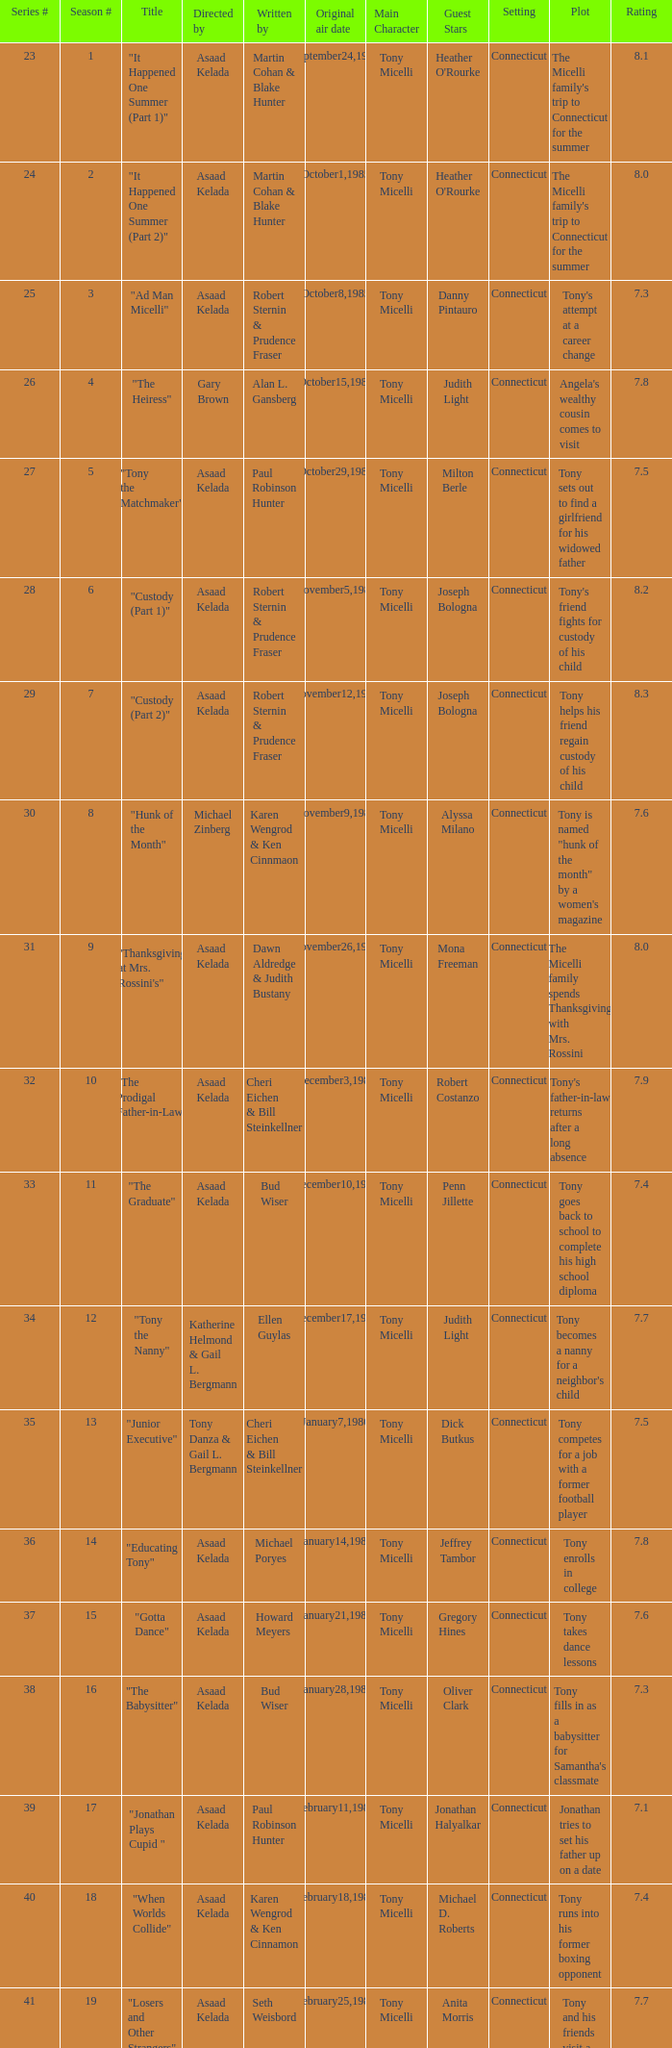What season features writer Michael Poryes? 14.0. 